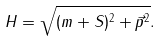Convert formula to latex. <formula><loc_0><loc_0><loc_500><loc_500>H = \sqrt { ( m + S ) ^ { 2 } + \vec { p } ^ { 2 } } .</formula> 